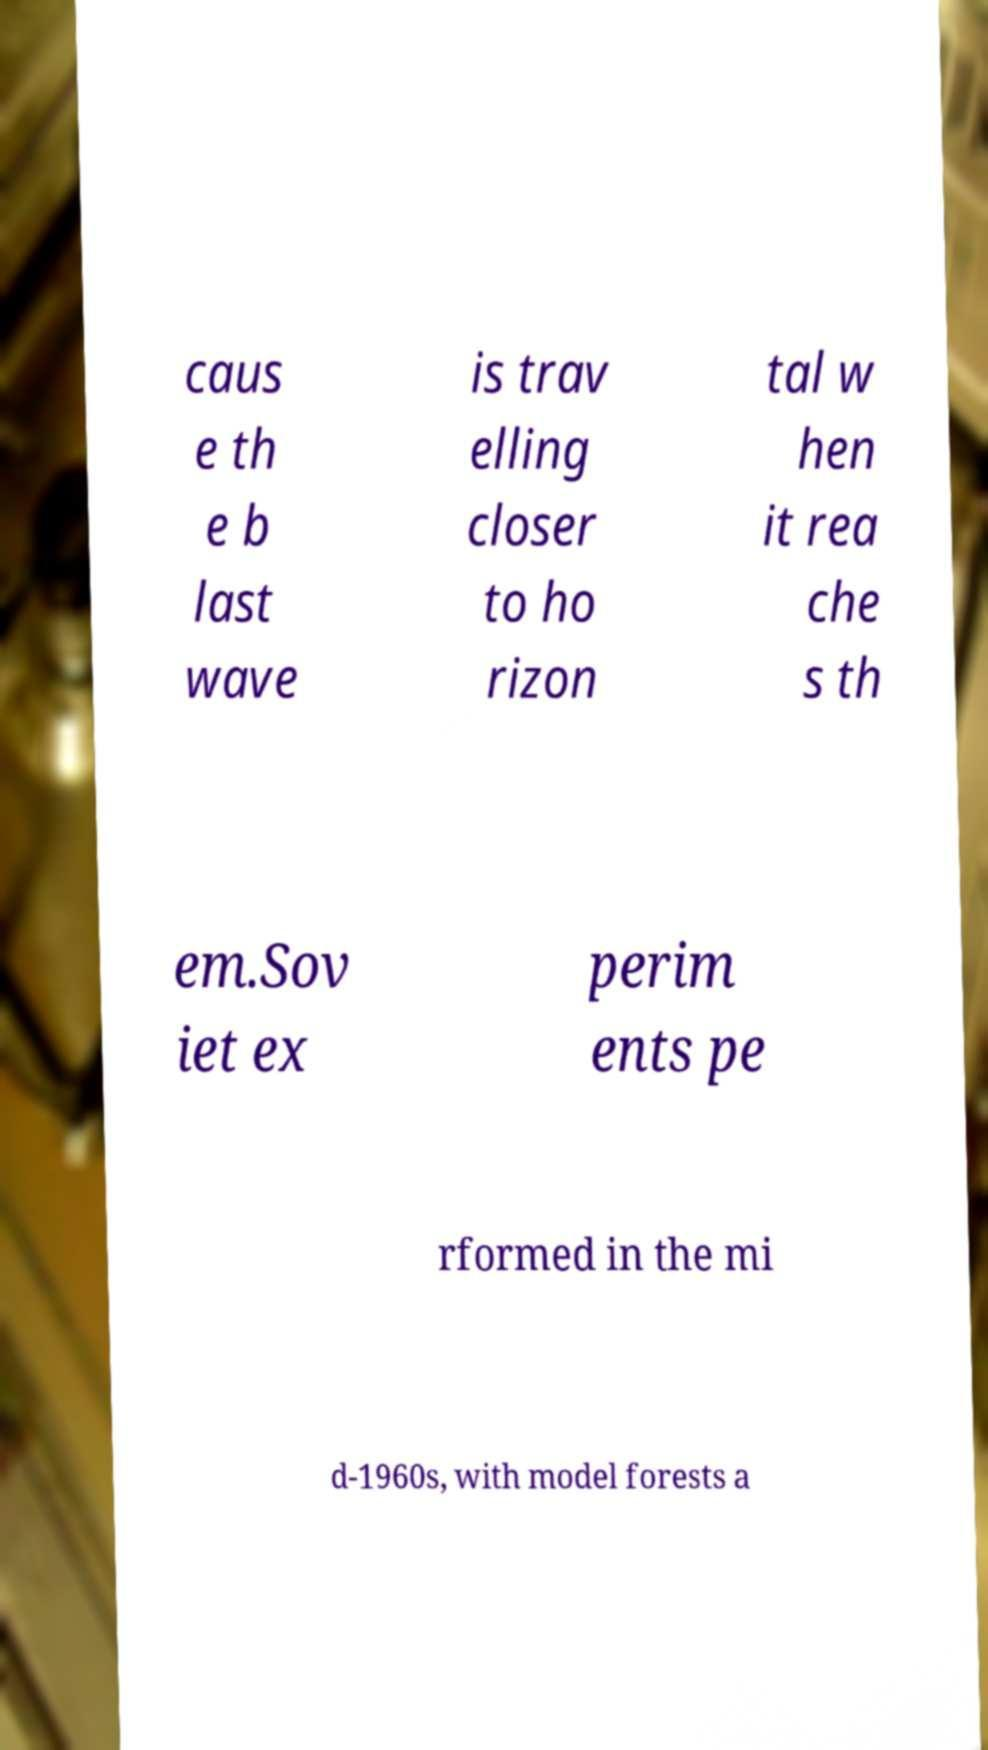Please identify and transcribe the text found in this image. caus e th e b last wave is trav elling closer to ho rizon tal w hen it rea che s th em.Sov iet ex perim ents pe rformed in the mi d-1960s, with model forests a 